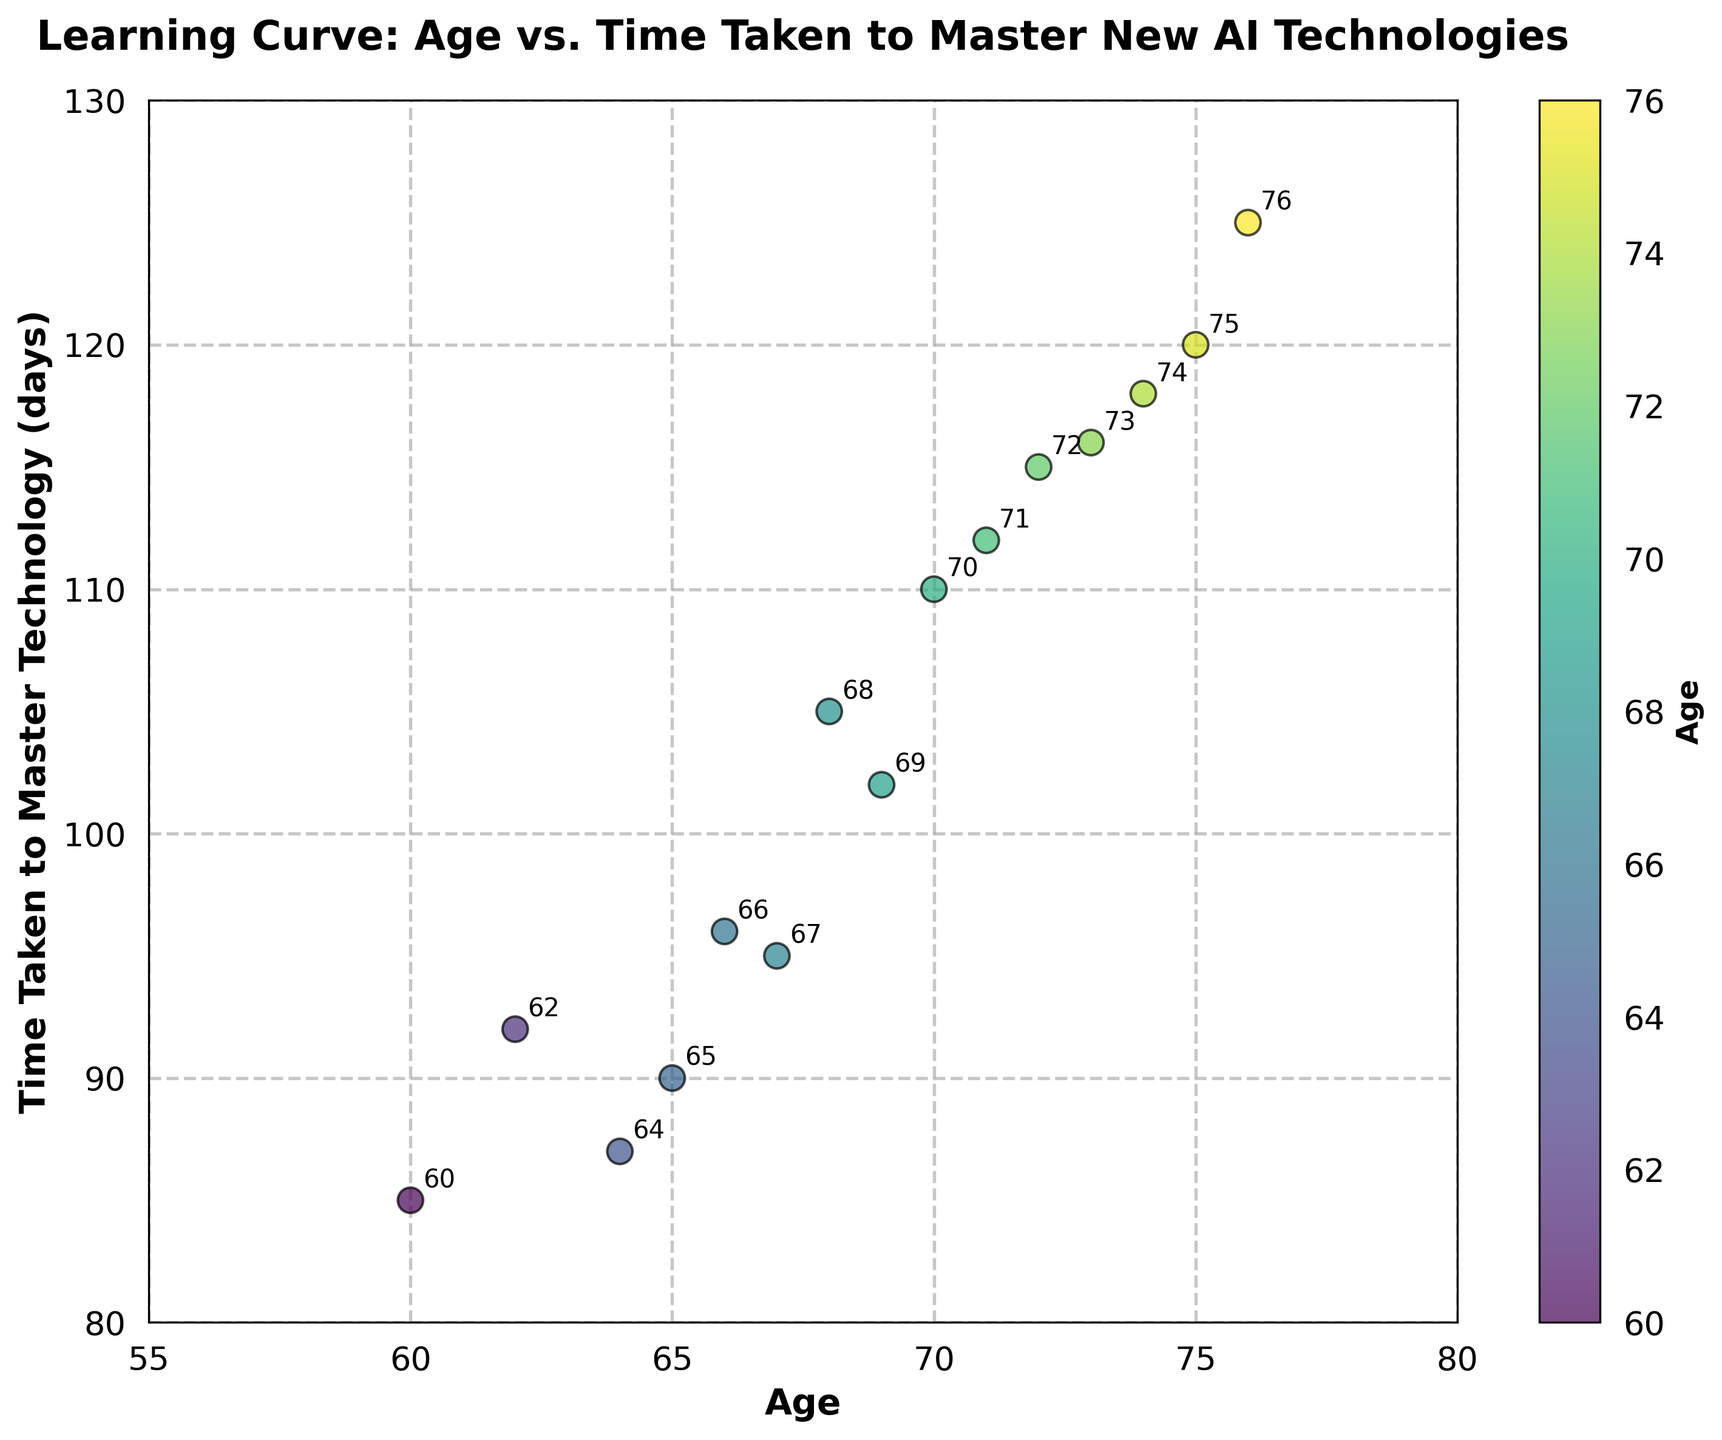How many data points are shown in the scatter plot? Count the number of points in the scatter plot. Each marker represents one data point.
Answer: 15 What is the title of the scatter plot? Look at the text at the top-center of the scatter plot. The title describes what the figure represents.
Answer: Learning Curve: Age vs. Time Taken to Master New AI Technologies What is the range of the x-axis? Check the minimum and maximum values shown along the x-axis.
Answer: 55 to 80 Which age group has the longest time to master the technology? Identify the data point with the highest y-value and note the corresponding x-value (age).
Answer: 76 What is the average time taken for those aged 70 and above to master the technology? First, identify all points with an age of 70 and above and then calculate the average y-value for these points. 110, 120, 118, 115, 116, 112, 125. Sum: 716, Count: 7, Average: 716/7 = 102.3
Answer: 102.3 What is the color scheme used in the scatter plot? Observe the color gradient applied to the points, which indicates the age.
Answer: Viridis Does the scatter plot show a clear trend between age and time taken to master the technology? Look for a pattern or trend in the data points' arrangement. Check if there's an increasing or decreasing pattern.
Answer: Yes, generally upward trend Which age group appears to be the fastest at mastering new technology? Identify the data point with the lowest y-value and note the corresponding x-value (age).
Answer: 60 What is the relationship between the color bar and the data points in the scatter plot? Observe how the colors of the data points correspond to the gradient displayed in the color bar, indicating age.
Answer: Represents age What annotation is placed near the data point for age 75? Find the data point corresponding to age 75 and read the associated annotation.
Answer: 75 